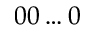Convert formula to latex. <formula><loc_0><loc_0><loc_500><loc_500>0 0 \dots 0</formula> 